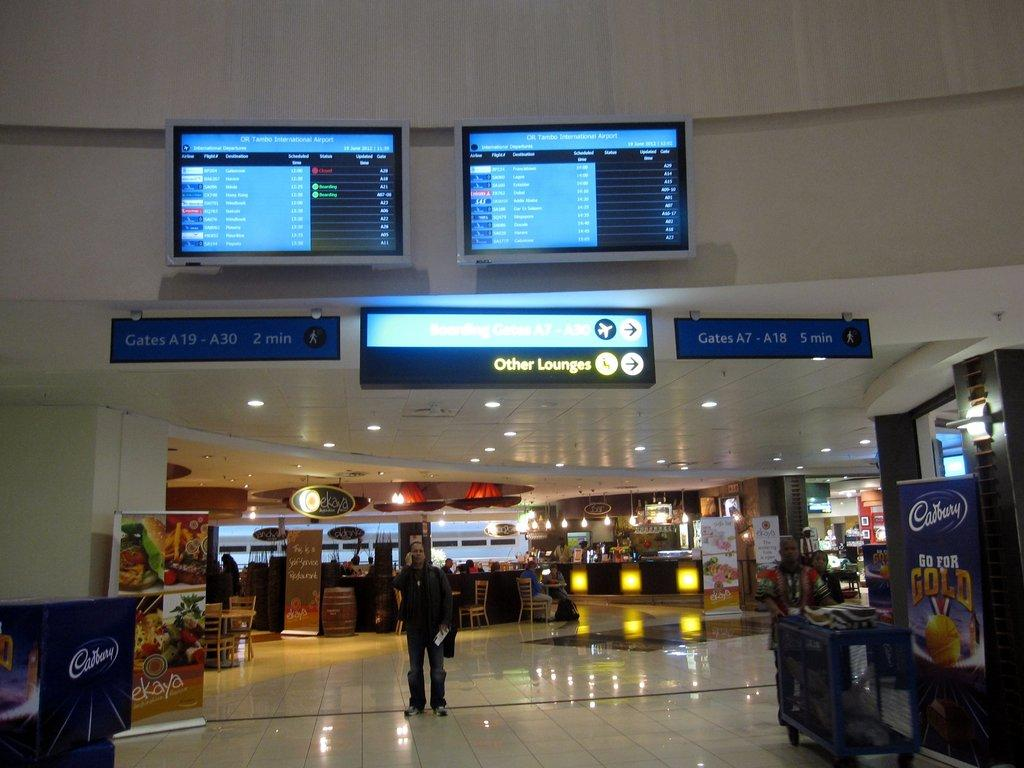What is located in the center of the image? There is a wall in the center of the image. What can be seen illuminating the area in the image? There are lights in the image. What type of furniture is present in the image? Chairs are present in the image. What type of decorations are visible in the image? Banners are visible in the image. What type of informational displays are present in the image? Sign boards are in the image. What type of display devices are present in the image? Screens are present in the image. Are there any people in the image? Yes, there are people in the image. Can you describe any other objects present in the image? There are a few other objects in the image, but their specific details are not mentioned in the provided facts. What type of ice is being discussed by the people in the image? There is no mention of ice or any discussion in the image. What is in the pocket of the person on the left side of the image? There is no information about pockets or the people's clothing in the image. 